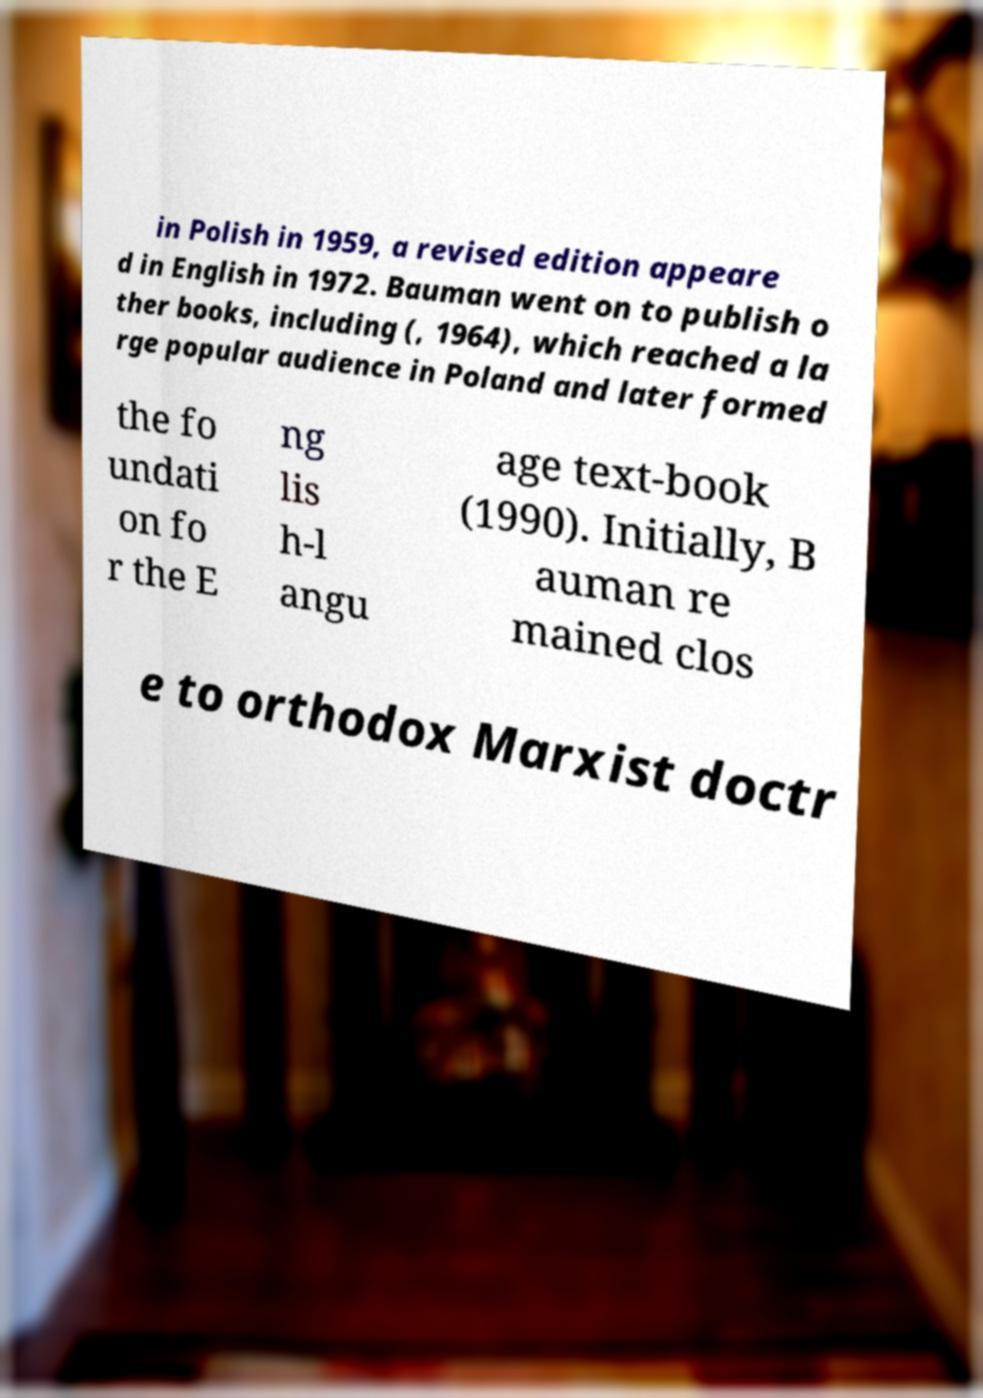Could you extract and type out the text from this image? in Polish in 1959, a revised edition appeare d in English in 1972. Bauman went on to publish o ther books, including (, 1964), which reached a la rge popular audience in Poland and later formed the fo undati on fo r the E ng lis h-l angu age text-book (1990). Initially, B auman re mained clos e to orthodox Marxist doctr 